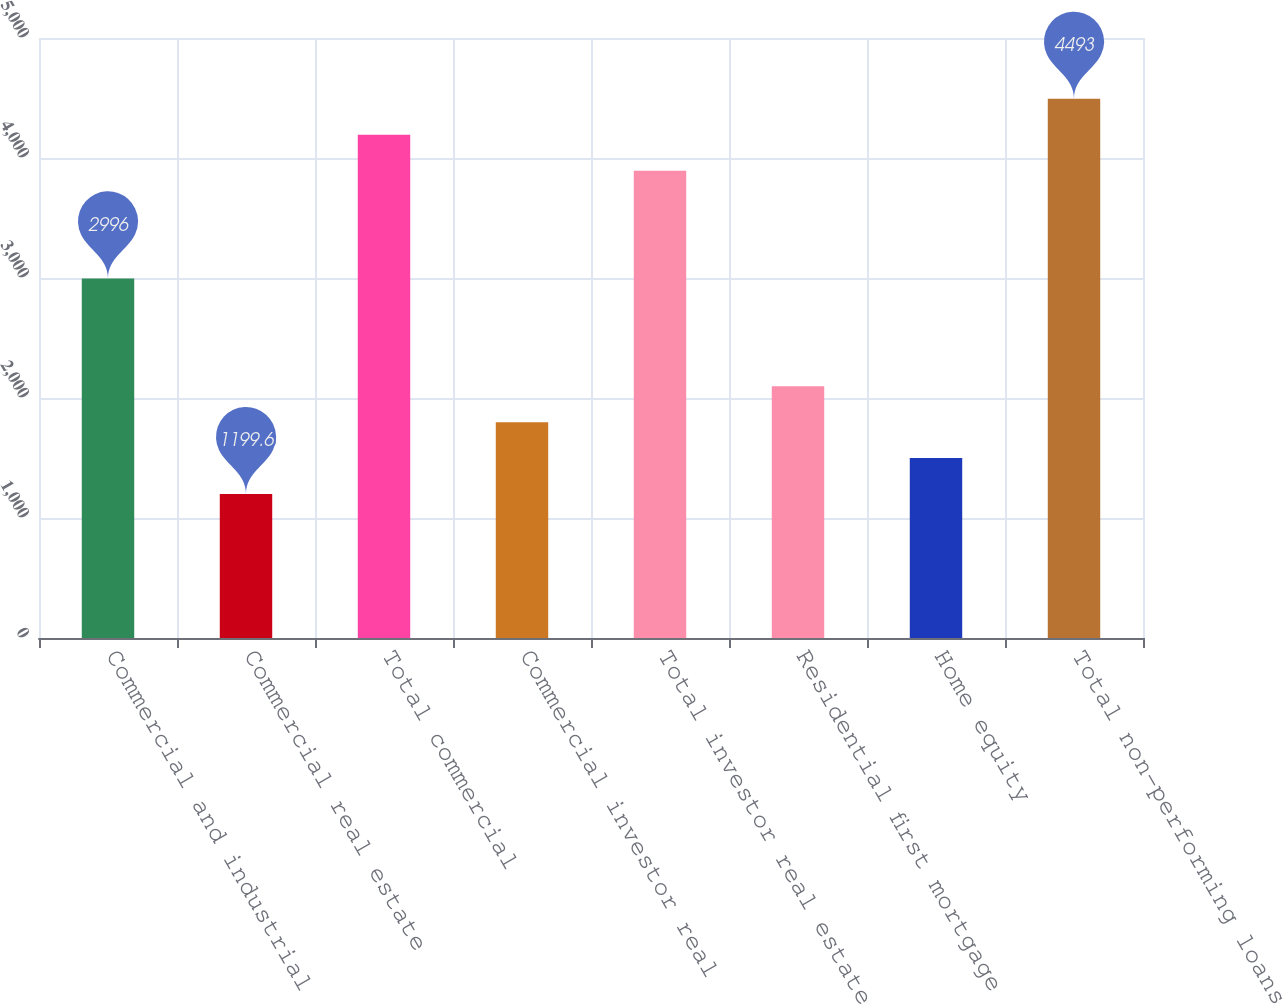Convert chart to OTSL. <chart><loc_0><loc_0><loc_500><loc_500><bar_chart><fcel>Commercial and industrial<fcel>Commercial real estate<fcel>Total commercial<fcel>Commercial investor real<fcel>Total investor real estate<fcel>Residential first mortgage<fcel>Home equity<fcel>Total non-performing loans<nl><fcel>2996<fcel>1199.6<fcel>4193.6<fcel>1798.4<fcel>3894.2<fcel>2097.8<fcel>1499<fcel>4493<nl></chart> 